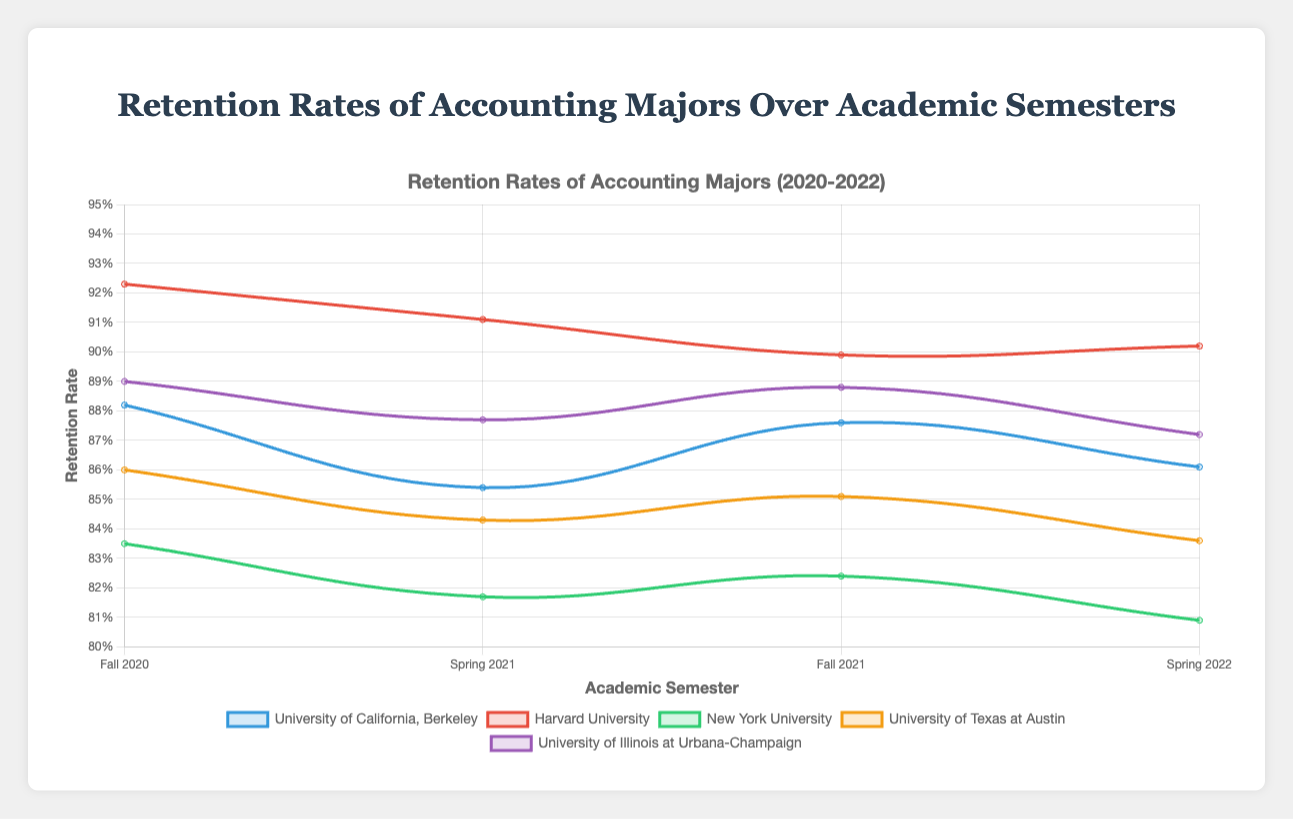1. Which university had the highest retention rate in Fall 2020? Look at the dataset labeled "Fall 2020" and compare the retention rates for each university. Harvard University had the highest retention rate of 92.3%.
Answer: Harvard University 2. What is the overall trend in retention rates for New York University from Fall 2020 to Spring 2022? Observing the line for New York University from Fall 2020 to Spring 2022, the retention rates decrease from 83.5% to 81.7%, then slightly increase to 82.4%, and finally decrease to 80.9%. The overall trend is a gradual decline.
Answer: Gradual decline 3. Between Spring 2021 and Spring 2022, which university showed an increase in retention rates? Compare the retention rates for each university between Spring 2021 and Spring 2022. Only University of California, Berkeley shows a slight increase from 85.4% to 86.1%.
Answer: University of California, Berkeley 4. Which university showed the most consistent retention rate (least variation) across all semesters? Calculate the variation (max-min) in retention rates for each university. UC Berkeley's variation is 88.2-85.4=2.8, Harvard is 92.3-89.9=2.4, NYU is 83.5-80.9=2.6, UT Austin is 86.0-83.6=2.4, and UIUC is 89.0-87.2=1.8. University of Illinois at Urbana-Champaign has the least variation.
Answer: University of Illinois at Urbana-Champaign 5. What is the average retention rate for Harvard University across all semesters? Sum the retention rates for Harvard University and divide by the number of semesters: (92.3 + 91.1 + 89.9 + 90.2) / 4 = 90.875%.
Answer: 90.875% 6. How did the retention rate for University of California, Berkeley change from Fall 2020 to Fall 2021? Compare the retention rates for Fall 2020 and Fall 2021. The retention rate decreased slightly from 88.2% to 87.6%.
Answer: Decreased slightly 7. Which university had the lowest retention rate in Spring 2022? Look at the dataset labeled "Spring 2022" and compare the retention rates. New York University had the lowest retention rate of 80.9%.
Answer: New York University 8. Did the retention rate for University of Texas at Austin increase or decrease from Spring 2021 to Fall 2021? Compare the retention rates for University of Texas at Austin between Spring 2021 and Fall 2021. The retention rate increased from 84.3% to 85.1%.
Answer: Increased 9. What's the difference between the highest and lowest retention rates for University of Illinois at Urbana-Champaign? Subtract the lowest retention rate from the highest retention rate for University of Illinois at Urbana-Champaign: 89.0 - 87.2 = 1.8%.
Answer: 1.8% 10. What can you conclude about the retention rates of Harvard University based on the plot? By observing the plotted retention rates for Harvard University, it maintains consistently high retention rates, diminishing slightly over time but still staying close to or above 90%.
Answer: Consistently high, slight decline 